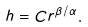<formula> <loc_0><loc_0><loc_500><loc_500>h = C r ^ { \beta / \alpha } .</formula> 